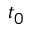Convert formula to latex. <formula><loc_0><loc_0><loc_500><loc_500>t _ { 0 }</formula> 